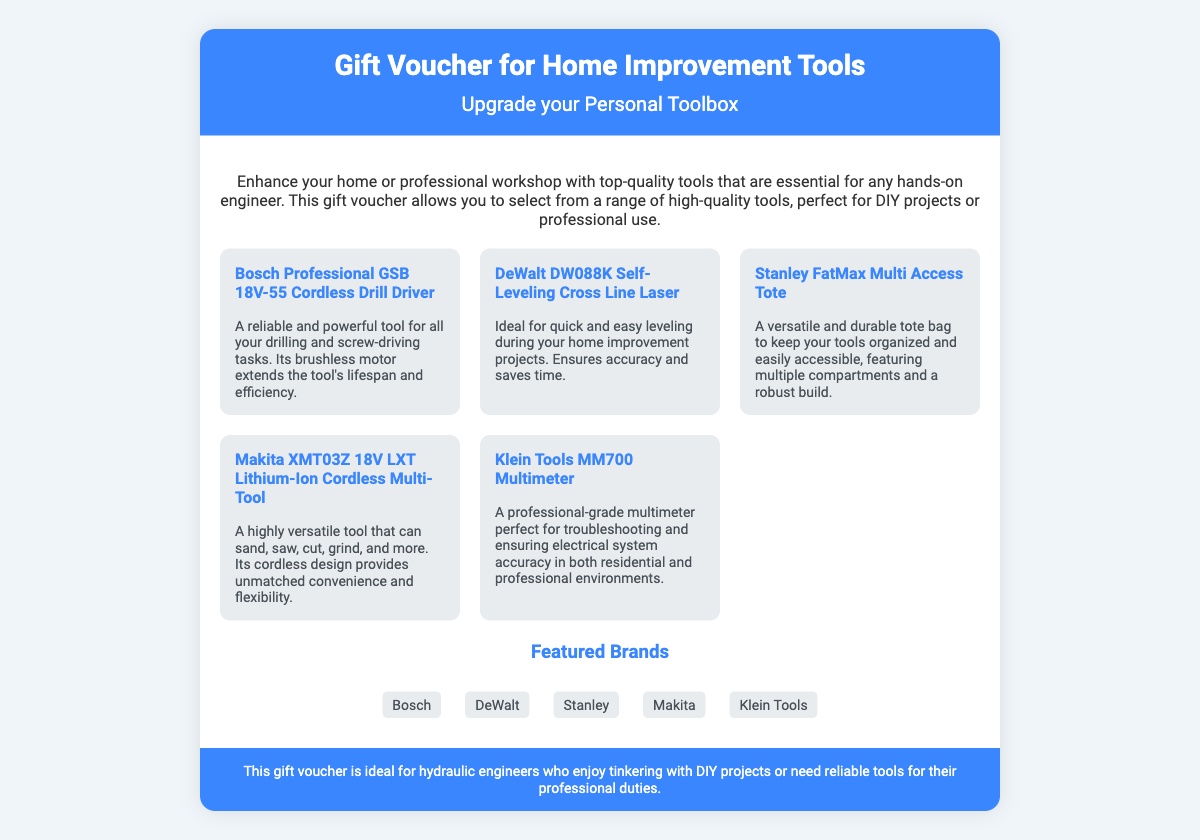What is the title of the gift voucher? The title prominently displayed in the document indicates the purpose of the voucher.
Answer: Gift Voucher for Home Improvement Tools What is the primary purpose of this gift voucher? The document clearly states that the voucher is aimed at enhancing a toolbox for engineering and DIY projects.
Answer: Upgrade your Personal Toolbox How many tools are featured in the document? The document lists a total number of tools in the tools section, showcasing the variety available.
Answer: Five What brand is associated with the cordless drill driver? The mention of the specific tool makes clear the brand's identity in the document.
Answer: Bosch Which tool is described as having a brushless motor? The description provided specifies the tool's features and advantages, leading to this identification.
Answer: Bosch Professional GSB 18V-55 Cordless Drill Driver What is the name of the self-leveling tool mentioned? The specific tool mentioned provides clarity on the type of equipment covered in the voucher.
Answer: DeWalt DW088K Self-Leveling Cross Line Laser Which brand appears most frequently in the feature list? Analyzing the list of brands presented will indicate their prominence with respect to the tools featured.
Answer: Bosch What utility does the Stanley FatMax Multi Access Tote provide? The document lists features of the tote, making its purpose clear without needing additional context.
Answer: Organizing tools Who is the intended audience of the gift voucher? The footer section of the voucher outlines the target audience explicitly.
Answer: Hydraulic engineers 